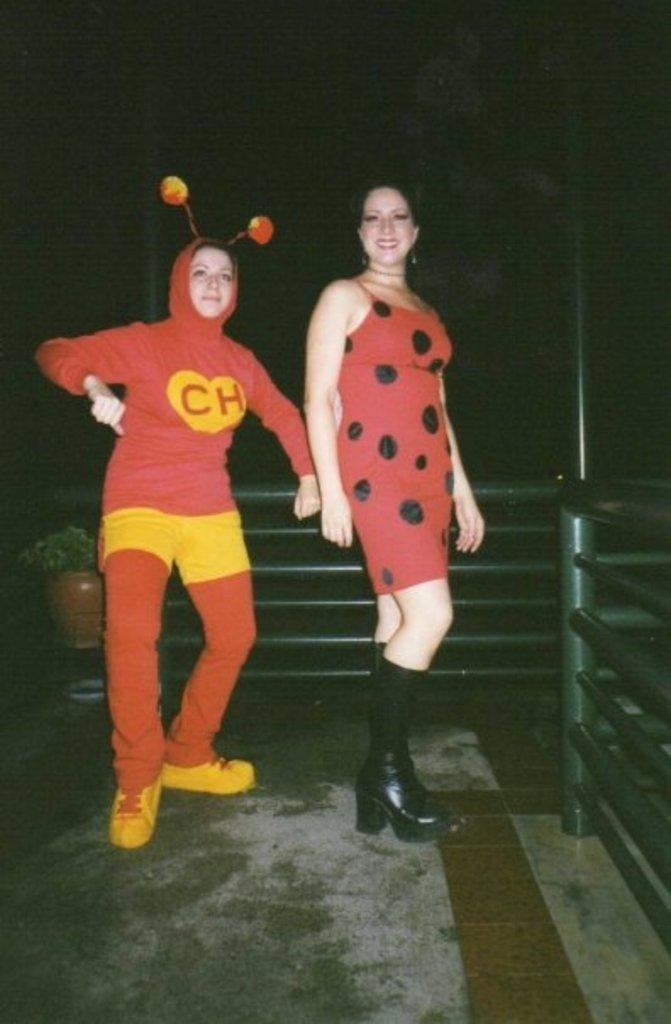How many people are in the image? There are two people in the image. What are the people wearing? The people are wearing different costumes. Where are the people standing? The people are standing on a surface. What can be seen in the background of the image? The background of the image is dark. What type of copper thing can be seen in the image? There is no copper thing present in the image. What thrilling activity are the people participating in within the image? The image does not depict any specific activity, and there is no indication of a thrilling activity taking place. 